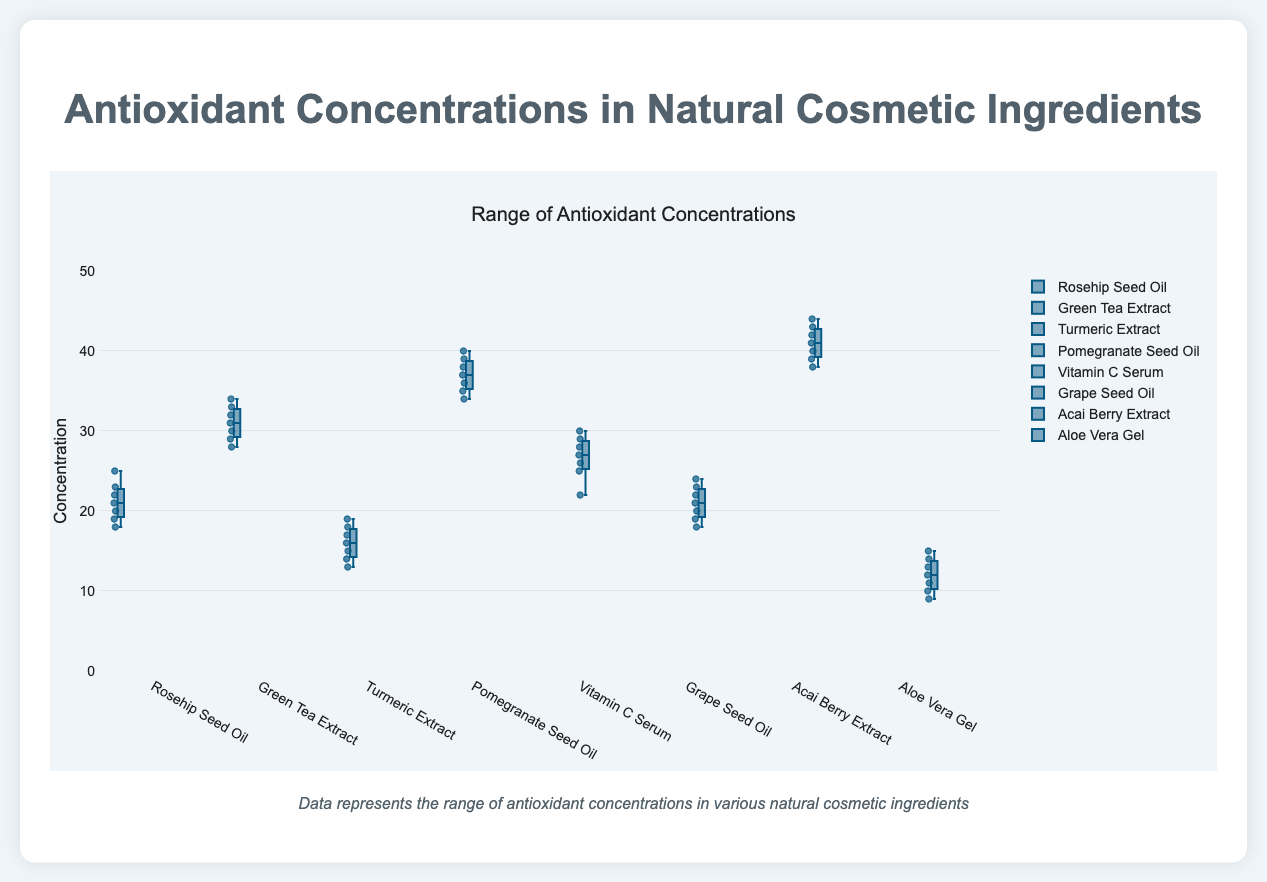What's the title of the plot? The title can be found at the top of the figure.
Answer: Antioxidant Concentrations in Natural Cosmetic Ingredients What is the median antioxidant concentration in Rosehip Seed Oil? The median value is the middle value when the data points are ordered. For Rosehip Seed Oil, the concentrations are [18, 19, 20, 21, 22, 23, 25]. The median is 21.
Answer: 21 Which ingredient has the lowest median antioxidant concentration? To find the lowest median, compare the median values of all ingredients. Aloe Vera Gel has the lowest median, which is 12.
Answer: Aloe Vera Gel How does the range of antioxidant concentration in Grape Seed Oil compare to that in Vitamin C Serum? The range is the difference between the highest and lowest values. Grape Seed Oil has a range of 24-18 = 6 and Vitamin C Serum has a range of 30-22 = 8. Therefore, Vitamin C Serum's range is larger.
Answer: Grape Seed Oil: 6, Vitamin C Serum: 8 What are the concentrations for Acai Berry Extract? The concentrations can be read directly from the data points represented in the box plot. Here they are: [40, 42, 39, 44, 41, 43, 38].
Answer: 40, 42, 39, 44, 41, 43, 38 Which ingredient shows the highest variability in antioxidant concentration? Variability in a box plot is often judged by the Interquartile Range (IQR), which is the length of the box. Pomegranate Seed Oil and Acai Berry Extract both have larger boxes compared to others, but Acai Berry Extract has more outliers indicating higher variability.
Answer: Acai Berry Extract Is the antioxidant concentration in Green Tea Extract more consistent than in Turmeric Extract? Consistency can be assessed by looking at the spread of the data and outliers. Green Tea Extract has a smaller IQR and fewer outliers compared to Turmeric Extract, indicating more consistency.
Answer: Yes What is the interquartile range (IQR) for Pomegranate Seed Oil? The IQR is the range between the 75th percentile (Q3) and the 25th percentile (Q1). For Pomegranate Seed Oil, Q1 is 35 and Q3 is 38. IQR = 38 - 35 = 3.
Answer: 3 Compare the maximum concentration values of Rosehip Seed Oil and Aloe Vera Gel. The maximum values from the box plots are the highest points. Rosehip Seed Oil's maximum is 25, and Aloe Vera Gel's maximum is 15.
Answer: Rosehip Seed Oil: 25, Aloe Vera Gel: 15 